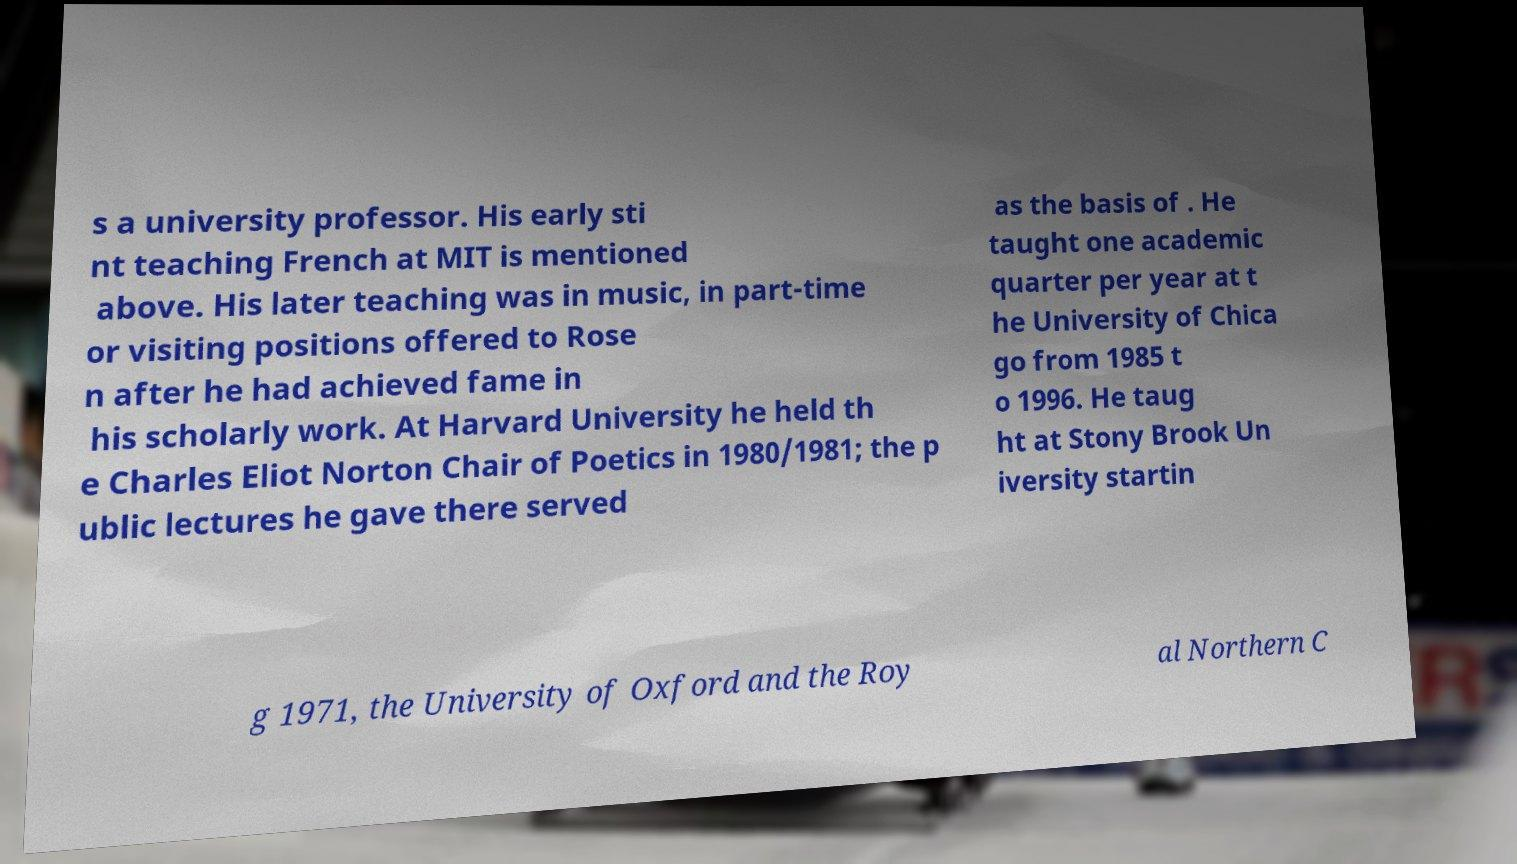What messages or text are displayed in this image? I need them in a readable, typed format. s a university professor. His early sti nt teaching French at MIT is mentioned above. His later teaching was in music, in part-time or visiting positions offered to Rose n after he had achieved fame in his scholarly work. At Harvard University he held th e Charles Eliot Norton Chair of Poetics in 1980/1981; the p ublic lectures he gave there served as the basis of . He taught one academic quarter per year at t he University of Chica go from 1985 t o 1996. He taug ht at Stony Brook Un iversity startin g 1971, the University of Oxford and the Roy al Northern C 